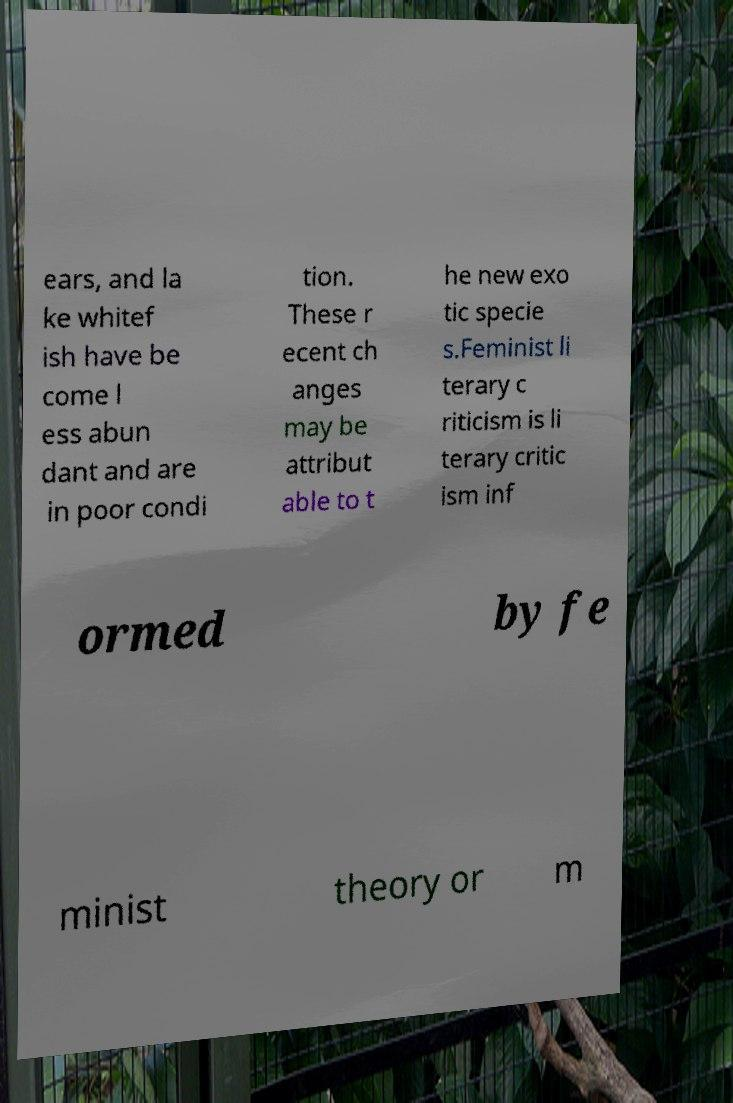Please identify and transcribe the text found in this image. ears, and la ke whitef ish have be come l ess abun dant and are in poor condi tion. These r ecent ch anges may be attribut able to t he new exo tic specie s.Feminist li terary c riticism is li terary critic ism inf ormed by fe minist theory or m 